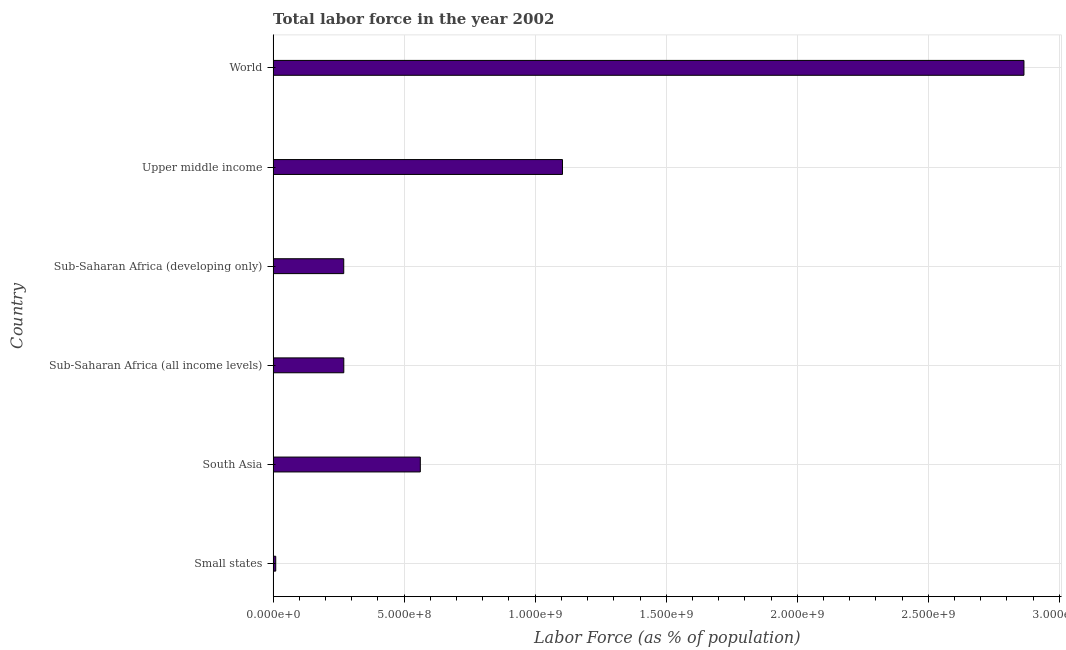Does the graph contain grids?
Give a very brief answer. Yes. What is the title of the graph?
Give a very brief answer. Total labor force in the year 2002. What is the label or title of the X-axis?
Ensure brevity in your answer.  Labor Force (as % of population). What is the total labor force in Sub-Saharan Africa (all income levels)?
Provide a succinct answer. 2.70e+08. Across all countries, what is the maximum total labor force?
Make the answer very short. 2.87e+09. Across all countries, what is the minimum total labor force?
Ensure brevity in your answer.  9.98e+06. In which country was the total labor force minimum?
Give a very brief answer. Small states. What is the sum of the total labor force?
Offer a terse response. 5.08e+09. What is the difference between the total labor force in South Asia and Upper middle income?
Your answer should be very brief. -5.43e+08. What is the average total labor force per country?
Ensure brevity in your answer.  8.47e+08. What is the median total labor force?
Your response must be concise. 4.16e+08. What is the ratio of the total labor force in South Asia to that in Sub-Saharan Africa (developing only)?
Offer a terse response. 2.08. What is the difference between the highest and the second highest total labor force?
Give a very brief answer. 1.76e+09. Is the sum of the total labor force in South Asia and World greater than the maximum total labor force across all countries?
Provide a succinct answer. Yes. What is the difference between the highest and the lowest total labor force?
Offer a terse response. 2.86e+09. How many bars are there?
Offer a very short reply. 6. How many countries are there in the graph?
Your answer should be very brief. 6. What is the difference between two consecutive major ticks on the X-axis?
Offer a terse response. 5.00e+08. What is the Labor Force (as % of population) in Small states?
Your answer should be very brief. 9.98e+06. What is the Labor Force (as % of population) in South Asia?
Keep it short and to the point. 5.62e+08. What is the Labor Force (as % of population) of Sub-Saharan Africa (all income levels)?
Provide a short and direct response. 2.70e+08. What is the Labor Force (as % of population) of Sub-Saharan Africa (developing only)?
Provide a succinct answer. 2.69e+08. What is the Labor Force (as % of population) in Upper middle income?
Your response must be concise. 1.10e+09. What is the Labor Force (as % of population) in World?
Provide a short and direct response. 2.87e+09. What is the difference between the Labor Force (as % of population) in Small states and South Asia?
Your response must be concise. -5.52e+08. What is the difference between the Labor Force (as % of population) in Small states and Sub-Saharan Africa (all income levels)?
Your response must be concise. -2.60e+08. What is the difference between the Labor Force (as % of population) in Small states and Sub-Saharan Africa (developing only)?
Your answer should be compact. -2.59e+08. What is the difference between the Labor Force (as % of population) in Small states and Upper middle income?
Provide a succinct answer. -1.09e+09. What is the difference between the Labor Force (as % of population) in Small states and World?
Make the answer very short. -2.86e+09. What is the difference between the Labor Force (as % of population) in South Asia and Sub-Saharan Africa (all income levels)?
Offer a terse response. 2.92e+08. What is the difference between the Labor Force (as % of population) in South Asia and Sub-Saharan Africa (developing only)?
Give a very brief answer. 2.92e+08. What is the difference between the Labor Force (as % of population) in South Asia and Upper middle income?
Offer a terse response. -5.43e+08. What is the difference between the Labor Force (as % of population) in South Asia and World?
Give a very brief answer. -2.30e+09. What is the difference between the Labor Force (as % of population) in Sub-Saharan Africa (all income levels) and Sub-Saharan Africa (developing only)?
Your response must be concise. 2.84e+05. What is the difference between the Labor Force (as % of population) in Sub-Saharan Africa (all income levels) and Upper middle income?
Offer a very short reply. -8.35e+08. What is the difference between the Labor Force (as % of population) in Sub-Saharan Africa (all income levels) and World?
Make the answer very short. -2.60e+09. What is the difference between the Labor Force (as % of population) in Sub-Saharan Africa (developing only) and Upper middle income?
Your answer should be compact. -8.35e+08. What is the difference between the Labor Force (as % of population) in Sub-Saharan Africa (developing only) and World?
Make the answer very short. -2.60e+09. What is the difference between the Labor Force (as % of population) in Upper middle income and World?
Offer a very short reply. -1.76e+09. What is the ratio of the Labor Force (as % of population) in Small states to that in South Asia?
Give a very brief answer. 0.02. What is the ratio of the Labor Force (as % of population) in Small states to that in Sub-Saharan Africa (all income levels)?
Your answer should be compact. 0.04. What is the ratio of the Labor Force (as % of population) in Small states to that in Sub-Saharan Africa (developing only)?
Your answer should be compact. 0.04. What is the ratio of the Labor Force (as % of population) in Small states to that in Upper middle income?
Make the answer very short. 0.01. What is the ratio of the Labor Force (as % of population) in Small states to that in World?
Ensure brevity in your answer.  0. What is the ratio of the Labor Force (as % of population) in South Asia to that in Sub-Saharan Africa (all income levels)?
Your answer should be compact. 2.08. What is the ratio of the Labor Force (as % of population) in South Asia to that in Sub-Saharan Africa (developing only)?
Make the answer very short. 2.08. What is the ratio of the Labor Force (as % of population) in South Asia to that in Upper middle income?
Give a very brief answer. 0.51. What is the ratio of the Labor Force (as % of population) in South Asia to that in World?
Provide a short and direct response. 0.2. What is the ratio of the Labor Force (as % of population) in Sub-Saharan Africa (all income levels) to that in Sub-Saharan Africa (developing only)?
Your answer should be very brief. 1. What is the ratio of the Labor Force (as % of population) in Sub-Saharan Africa (all income levels) to that in Upper middle income?
Your answer should be very brief. 0.24. What is the ratio of the Labor Force (as % of population) in Sub-Saharan Africa (all income levels) to that in World?
Provide a succinct answer. 0.09. What is the ratio of the Labor Force (as % of population) in Sub-Saharan Africa (developing only) to that in Upper middle income?
Provide a short and direct response. 0.24. What is the ratio of the Labor Force (as % of population) in Sub-Saharan Africa (developing only) to that in World?
Your answer should be compact. 0.09. What is the ratio of the Labor Force (as % of population) in Upper middle income to that in World?
Your answer should be compact. 0.39. 